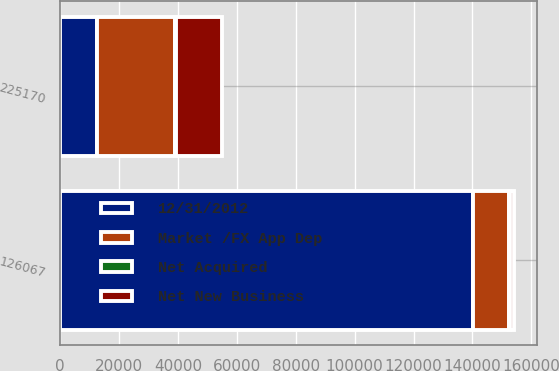<chart> <loc_0><loc_0><loc_500><loc_500><stacked_bar_chart><ecel><fcel>126067<fcel>225170<nl><fcel>Net New Business<fcel>1575<fcel>15817<nl><fcel>Net Acquired<fcel>78<fcel>78<nl><fcel>Market /FX App Dep<fcel>12440<fcel>26683<nl><fcel>12/31/2012<fcel>140160<fcel>12440<nl></chart> 